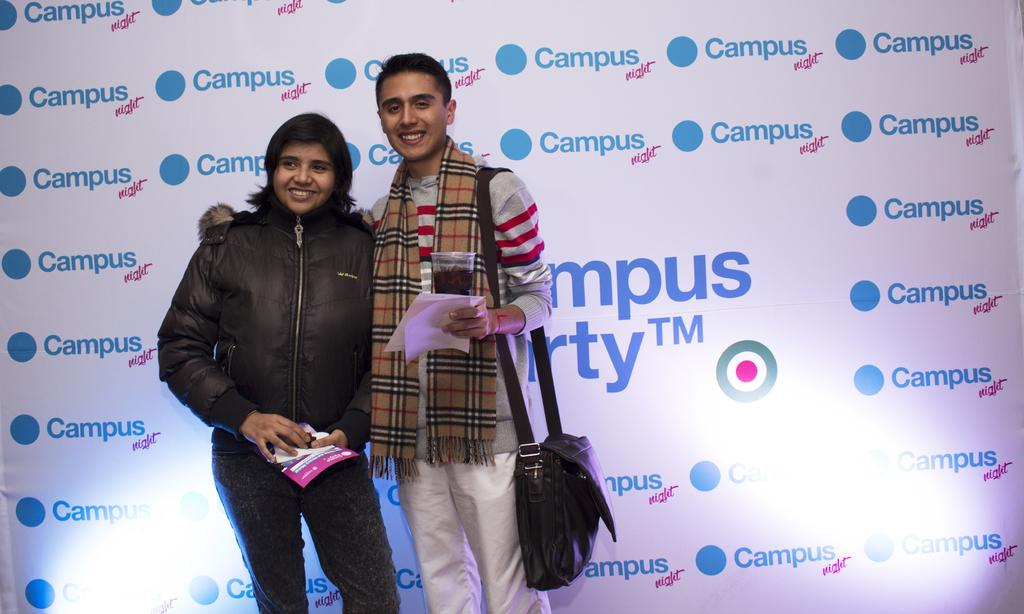How many people are in the image? There are two people in the image. What are the people doing in the image? The people are standing and holding papers. What else can be seen in the image besides the people? There is a board visible in the image. What type of nerve is being studied on the board in the image? There is no nerve or any indication of a scientific study in the image; it simply shows two people standing and holding papers. 